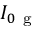Convert formula to latex. <formula><loc_0><loc_0><loc_500><loc_500>I _ { 0 g }</formula> 